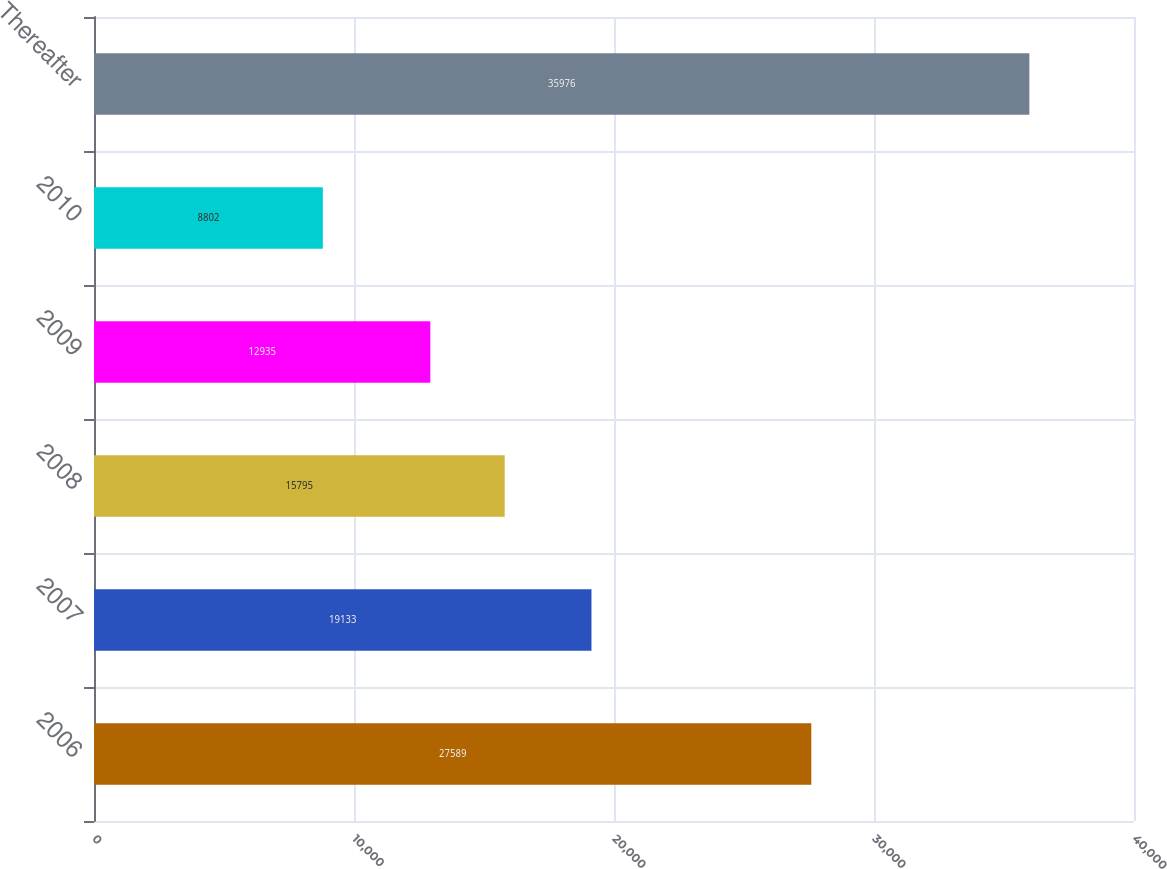<chart> <loc_0><loc_0><loc_500><loc_500><bar_chart><fcel>2006<fcel>2007<fcel>2008<fcel>2009<fcel>2010<fcel>Thereafter<nl><fcel>27589<fcel>19133<fcel>15795<fcel>12935<fcel>8802<fcel>35976<nl></chart> 